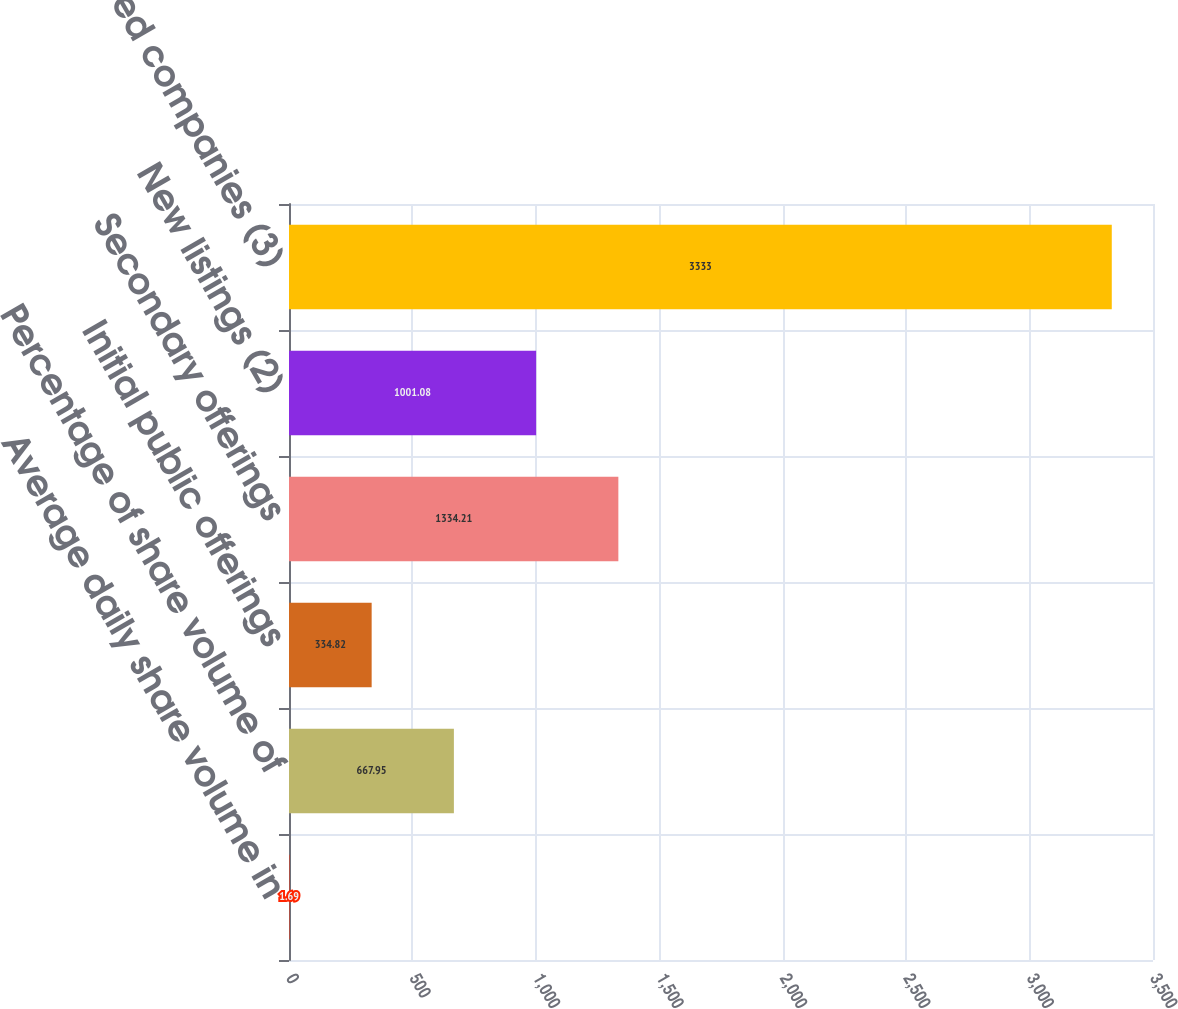Convert chart. <chart><loc_0><loc_0><loc_500><loc_500><bar_chart><fcel>Average daily share volume in<fcel>Percentage of share volume of<fcel>Initial public offerings<fcel>Secondary offerings<fcel>New listings (2)<fcel>Number of listed companies (3)<nl><fcel>1.69<fcel>667.95<fcel>334.82<fcel>1334.21<fcel>1001.08<fcel>3333<nl></chart> 